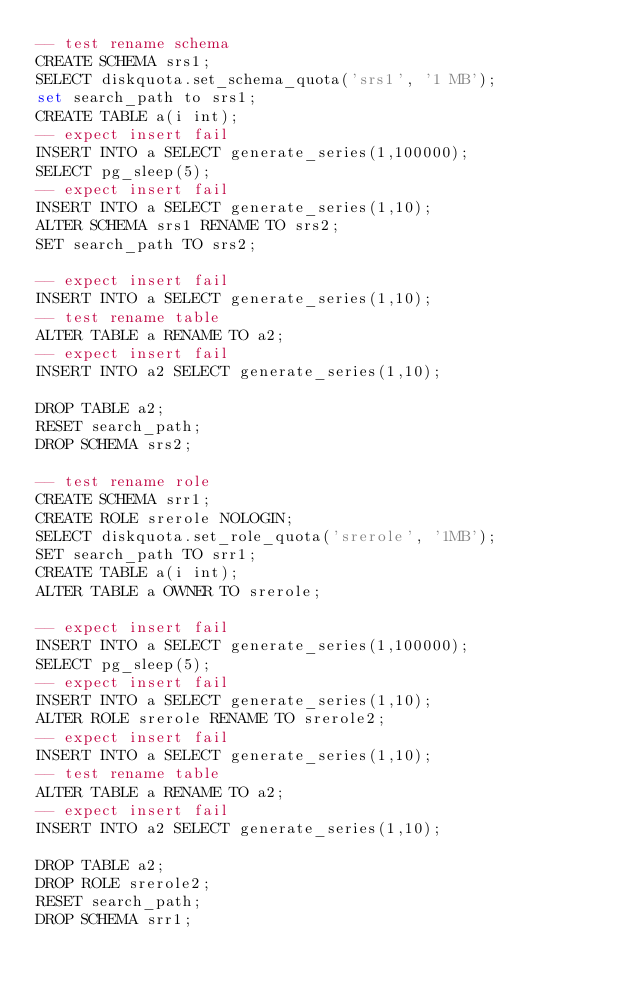<code> <loc_0><loc_0><loc_500><loc_500><_SQL_>-- test rename schema
CREATE SCHEMA srs1;
SELECT diskquota.set_schema_quota('srs1', '1 MB');
set search_path to srs1;
CREATE TABLE a(i int);
-- expect insert fail
INSERT INTO a SELECT generate_series(1,100000);
SELECT pg_sleep(5);
-- expect insert fail
INSERT INTO a SELECT generate_series(1,10);
ALTER SCHEMA srs1 RENAME TO srs2;
SET search_path TO srs2;

-- expect insert fail
INSERT INTO a SELECT generate_series(1,10);
-- test rename table
ALTER TABLE a RENAME TO a2;
-- expect insert fail
INSERT INTO a2 SELECT generate_series(1,10);

DROP TABLE a2;
RESET search_path;
DROP SCHEMA srs2;

-- test rename role
CREATE SCHEMA srr1;
CREATE ROLE srerole NOLOGIN;
SELECT diskquota.set_role_quota('srerole', '1MB');
SET search_path TO srr1;
CREATE TABLE a(i int);
ALTER TABLE a OWNER TO srerole;

-- expect insert fail
INSERT INTO a SELECT generate_series(1,100000);
SELECT pg_sleep(5);
-- expect insert fail
INSERT INTO a SELECT generate_series(1,10);
ALTER ROLE srerole RENAME TO srerole2;
-- expect insert fail
INSERT INTO a SELECT generate_series(1,10);
-- test rename table
ALTER TABLE a RENAME TO a2;
-- expect insert fail
INSERT INTO a2 SELECT generate_series(1,10);

DROP TABLE a2;
DROP ROLE srerole2;
RESET search_path;
DROP SCHEMA srr1;

</code> 